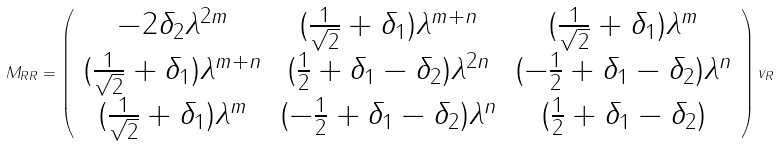Convert formula to latex. <formula><loc_0><loc_0><loc_500><loc_500>M _ { R R } = \left ( \begin{array} { c c c } - 2 \delta _ { 2 } \lambda ^ { 2 m } & ( \frac { 1 } { \sqrt { 2 } } + \delta _ { 1 } ) \lambda ^ { m + n } & ( \frac { 1 } { \sqrt { 2 } } + \delta _ { 1 } ) \lambda ^ { m } \\ ( \frac { 1 } { \sqrt { 2 } } + \delta _ { 1 } ) \lambda ^ { m + n } & ( \frac { 1 } { 2 } + \delta _ { 1 } - \delta _ { 2 } ) \lambda ^ { 2 n } & ( - \frac { 1 } { 2 } + \delta _ { 1 } - \delta _ { 2 } ) \lambda ^ { n } \\ ( \frac { 1 } { \sqrt { 2 } } + \delta _ { 1 } ) \lambda ^ { m } & ( - \frac { 1 } { 2 } + \delta _ { 1 } - \delta _ { 2 } ) \lambda ^ { n } & ( \frac { 1 } { 2 } + \delta _ { 1 } - \delta _ { 2 } ) \end{array} \right ) v _ { R }</formula> 